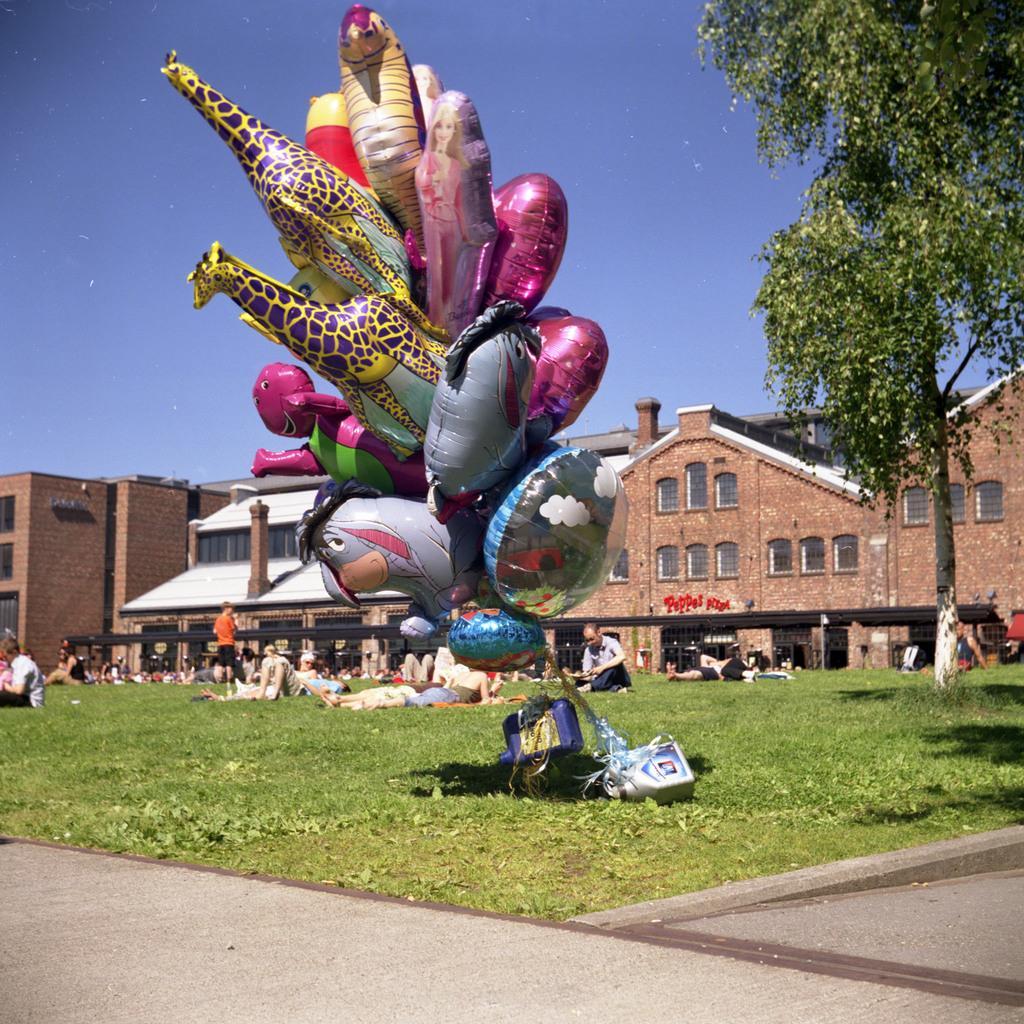In one or two sentences, can you explain what this image depicts? In the background portion of the picture we can see the sky, buildings, windows. In this picture we can see the people. Few are resting on the grass. On the right side of the picture we can see a tree. At the bottom portion of the picture we can see the road. This picture is mainly highlighted with the colorful inflatable objects. 